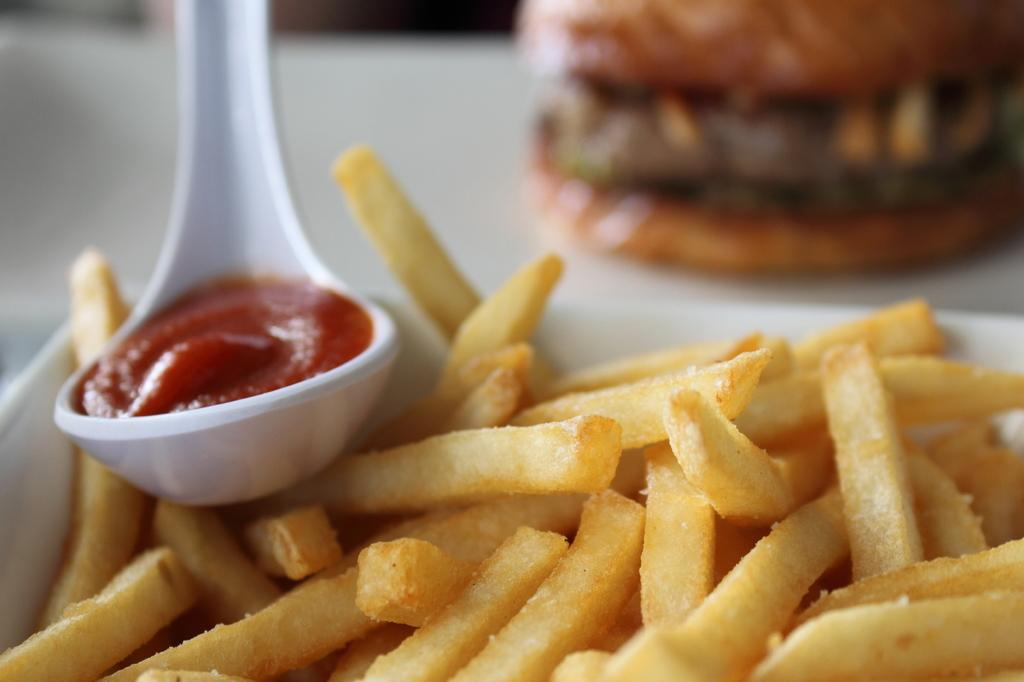What utensil is visible in the image? There is a spoon in the image. What type of item can be seen in the image besides the spoon? There is a food item in the image. What is the color of the object containing the food item? The food item is in a white color object. How would you describe the background of the image? The background of the image is blurred. How many snails can be seen crawling on the food item in the image? There are no snails present in the image. What type of animal is hiding behind the white color object in the image? There is no animal present in the image. 